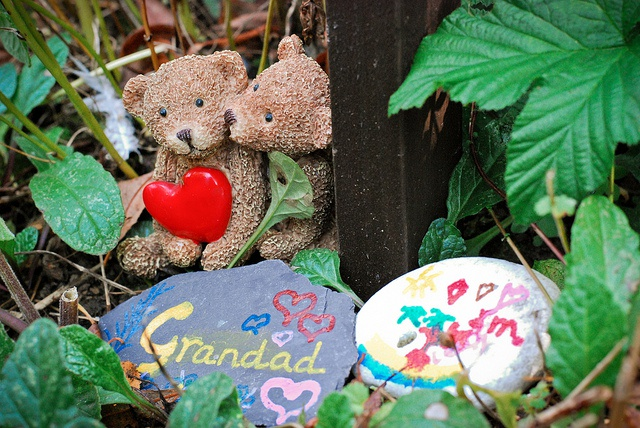Describe the objects in this image and their specific colors. I can see teddy bear in black, tan, and gray tones and teddy bear in black, tan, brown, and darkgray tones in this image. 